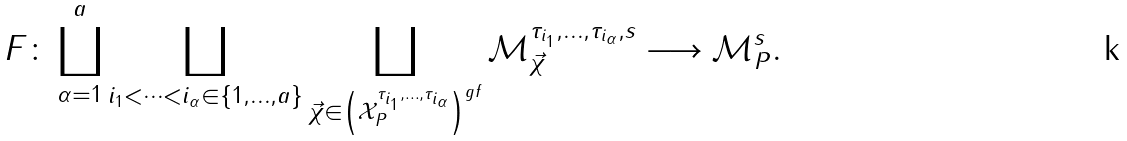<formula> <loc_0><loc_0><loc_500><loc_500>F \colon \coprod _ { \alpha = 1 } ^ { a } \coprod _ { i _ { 1 } < \cdots < i _ { \alpha } \in \{ 1 , \dots , a \} } \coprod _ { \vec { \chi } \in \left ( \mathcal { X } _ { P } ^ { \tau _ { i _ { 1 } } , \dots , \tau _ { i _ { \alpha } } } \right ) ^ { g f } } \mathcal { M } _ { \vec { \chi } } ^ { \tau _ { i _ { 1 } } , \dots , \tau _ { i _ { \alpha } } , s } \longrightarrow \mathcal { M } _ { P } ^ { s } .</formula> 